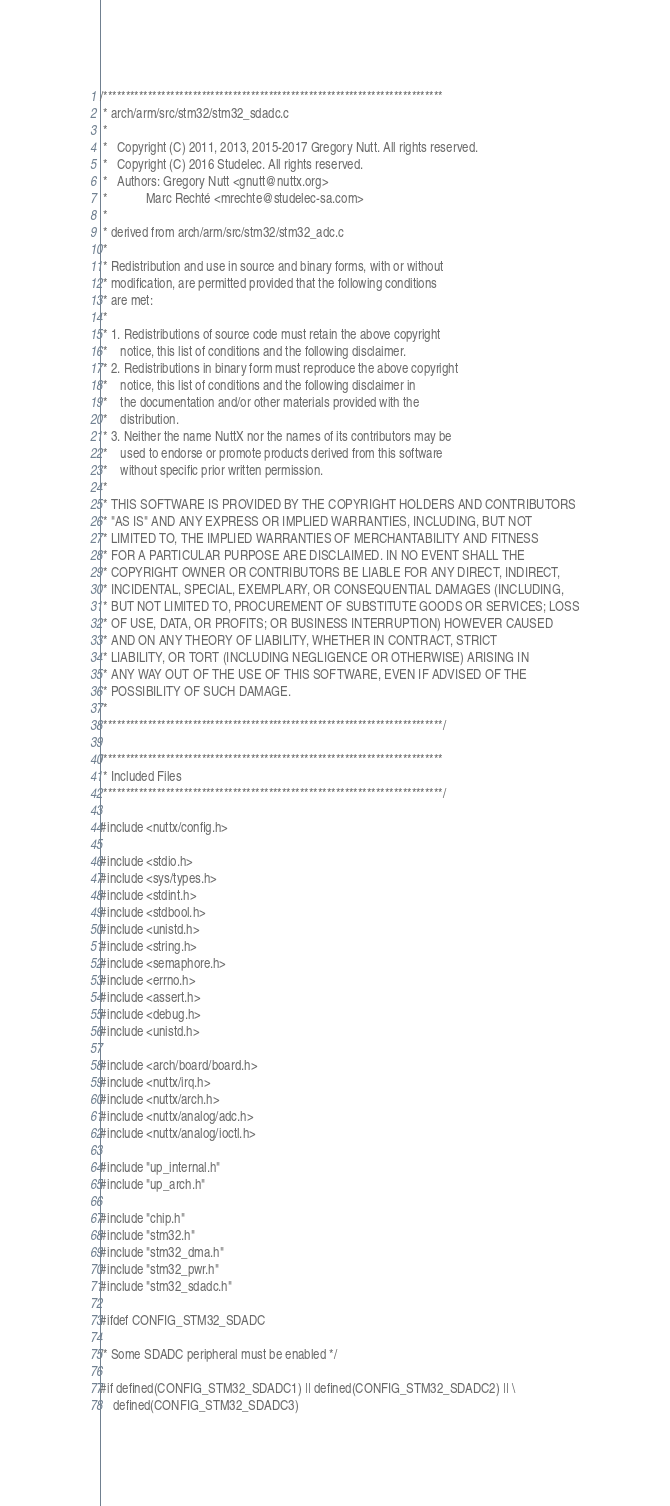<code> <loc_0><loc_0><loc_500><loc_500><_C_>/****************************************************************************
 * arch/arm/src/stm32/stm32_sdadc.c
 *
 *   Copyright (C) 2011, 2013, 2015-2017 Gregory Nutt. All rights reserved.
 *   Copyright (C) 2016 Studelec. All rights reserved.
 *   Authors: Gregory Nutt <gnutt@nuttx.org>
 *            Marc Rechté <mrechte@studelec-sa.com>
 *
 * derived from arch/arm/src/stm32/stm32_adc.c
 *
 * Redistribution and use in source and binary forms, with or without
 * modification, are permitted provided that the following conditions
 * are met:
 *
 * 1. Redistributions of source code must retain the above copyright
 *    notice, this list of conditions and the following disclaimer.
 * 2. Redistributions in binary form must reproduce the above copyright
 *    notice, this list of conditions and the following disclaimer in
 *    the documentation and/or other materials provided with the
 *    distribution.
 * 3. Neither the name NuttX nor the names of its contributors may be
 *    used to endorse or promote products derived from this software
 *    without specific prior written permission.
 *
 * THIS SOFTWARE IS PROVIDED BY THE COPYRIGHT HOLDERS AND CONTRIBUTORS
 * "AS IS" AND ANY EXPRESS OR IMPLIED WARRANTIES, INCLUDING, BUT NOT
 * LIMITED TO, THE IMPLIED WARRANTIES OF MERCHANTABILITY AND FITNESS
 * FOR A PARTICULAR PURPOSE ARE DISCLAIMED. IN NO EVENT SHALL THE
 * COPYRIGHT OWNER OR CONTRIBUTORS BE LIABLE FOR ANY DIRECT, INDIRECT,
 * INCIDENTAL, SPECIAL, EXEMPLARY, OR CONSEQUENTIAL DAMAGES (INCLUDING,
 * BUT NOT LIMITED TO, PROCUREMENT OF SUBSTITUTE GOODS OR SERVICES; LOSS
 * OF USE, DATA, OR PROFITS; OR BUSINESS INTERRUPTION) HOWEVER CAUSED
 * AND ON ANY THEORY OF LIABILITY, WHETHER IN CONTRACT, STRICT
 * LIABILITY, OR TORT (INCLUDING NEGLIGENCE OR OTHERWISE) ARISING IN
 * ANY WAY OUT OF THE USE OF THIS SOFTWARE, EVEN IF ADVISED OF THE
 * POSSIBILITY OF SUCH DAMAGE.
 *
 ****************************************************************************/

/****************************************************************************
 * Included Files
 ****************************************************************************/

#include <nuttx/config.h>

#include <stdio.h>
#include <sys/types.h>
#include <stdint.h>
#include <stdbool.h>
#include <unistd.h>
#include <string.h>
#include <semaphore.h>
#include <errno.h>
#include <assert.h>
#include <debug.h>
#include <unistd.h>

#include <arch/board/board.h>
#include <nuttx/irq.h>
#include <nuttx/arch.h>
#include <nuttx/analog/adc.h>
#include <nuttx/analog/ioctl.h>

#include "up_internal.h"
#include "up_arch.h"

#include "chip.h"
#include "stm32.h"
#include "stm32_dma.h"
#include "stm32_pwr.h"
#include "stm32_sdadc.h"

#ifdef CONFIG_STM32_SDADC

/* Some SDADC peripheral must be enabled */

#if defined(CONFIG_STM32_SDADC1) || defined(CONFIG_STM32_SDADC2) || \
    defined(CONFIG_STM32_SDADC3)
</code> 